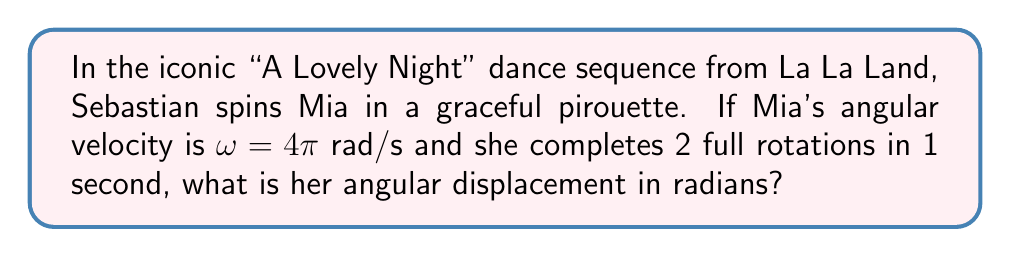Can you answer this question? Let's approach this step-by-step using rotational kinematics:

1) First, recall the equation for angular displacement $\theta$ in terms of angular velocity $\omega$ and time $t$:

   $$\theta = \omega t$$

2) We're given that Mia's angular velocity $\omega = 4\pi$ rad/s.

3) We're also told that she completes 2 full rotations in 1 second. This information serves as a check for our calculation.

4) Substituting the values into our equation:

   $$\theta = (4\pi \text{ rad/s})(1 \text{ s}) = 4\pi \text{ rad}$$

5) To verify, let's check if this makes sense with the given information about full rotations:
   - One full rotation is $2\pi$ radians
   - Two full rotations would be $2(2\pi) = 4\pi$ radians

   This matches our calculated result, confirming our answer.
Answer: $4\pi$ rad 